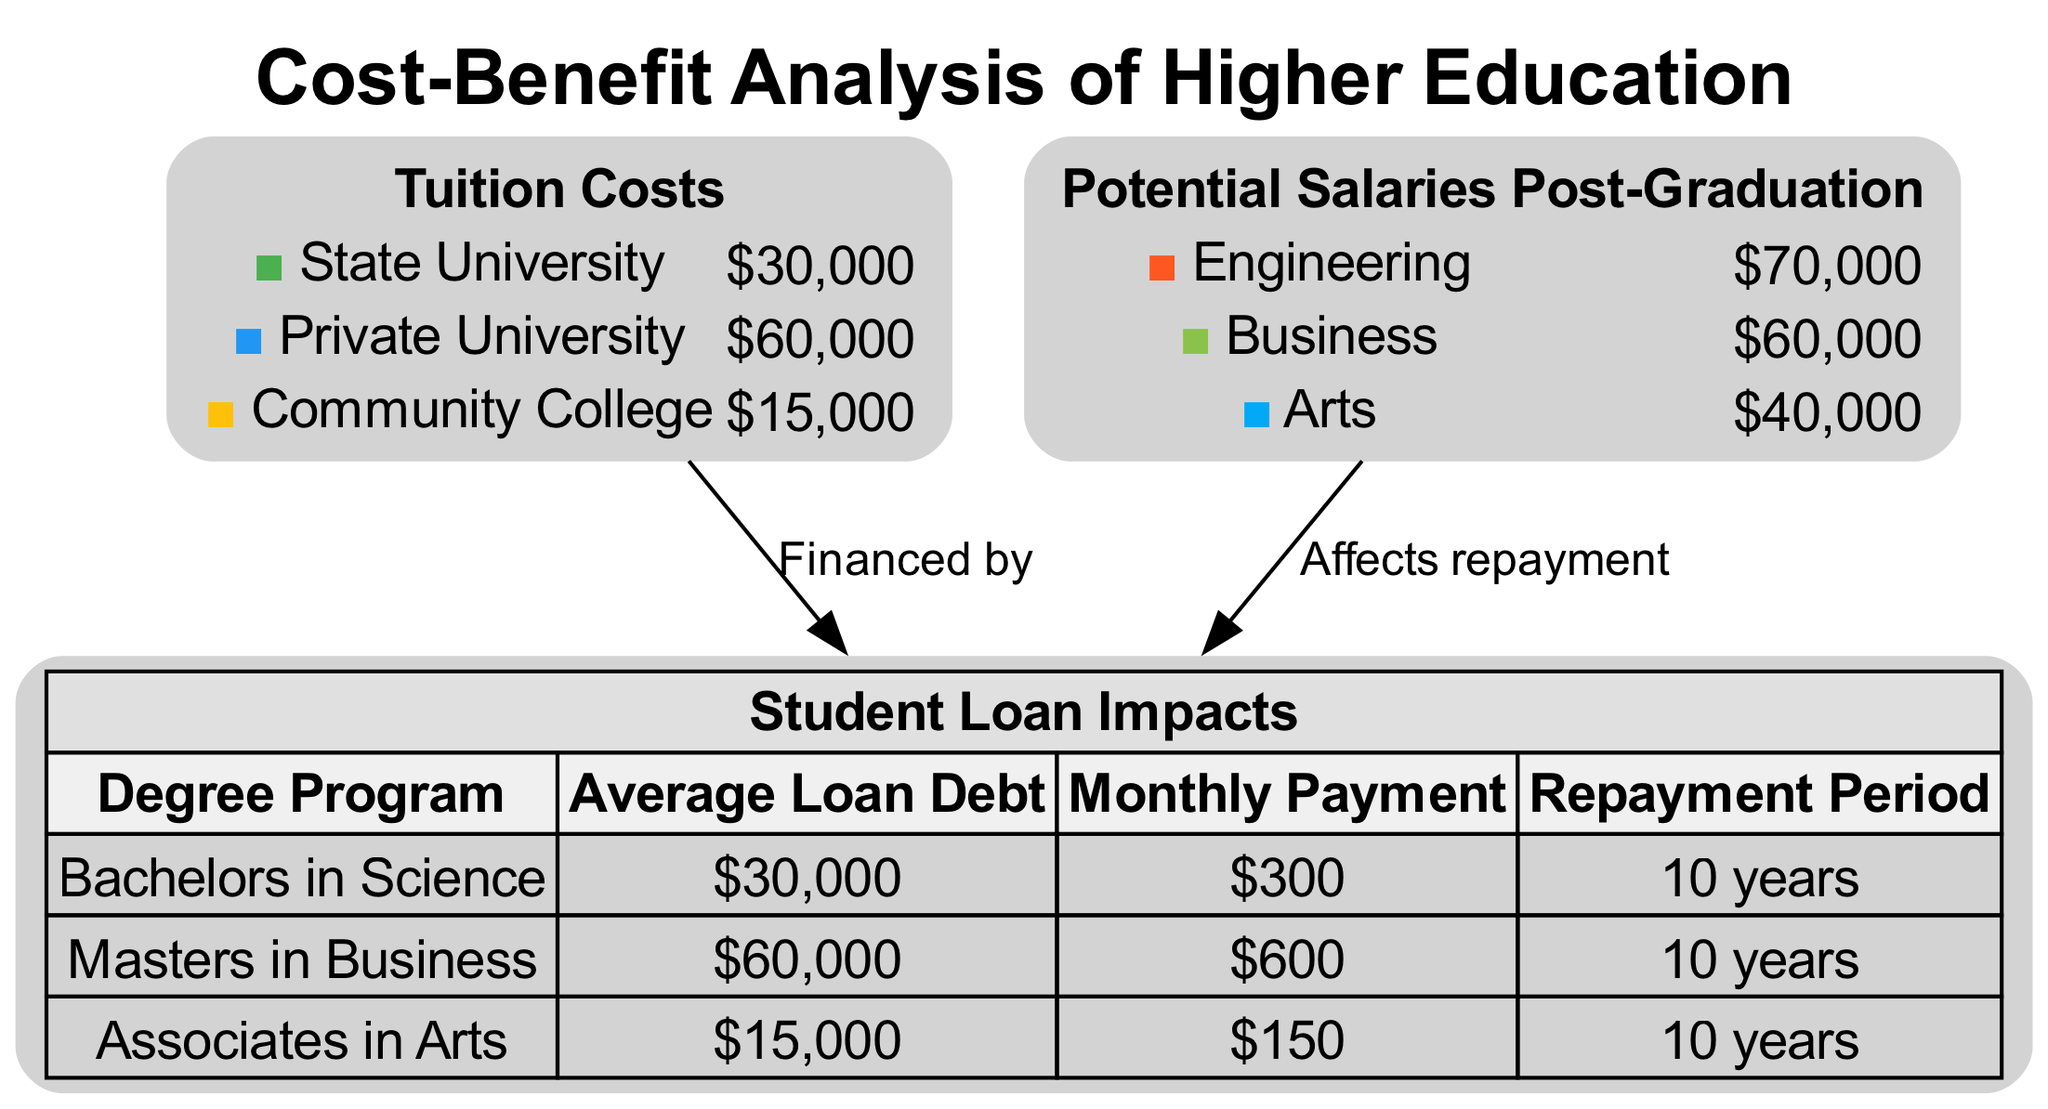What is the tuition cost for a Private University? The diagram shows that the "Private University" segment of the "Tuition Costs" pie chart has a value of $60,000.
Answer: $60,000 What is the monthly payment for a Masters in Business? In the table titled "Student Loan Impacts," the row corresponding to "Masters in Business" indicates an average monthly payment of $600.
Answer: $600 Which degree program has the lowest average loan debt? Referring to the table, the "Associates in Arts" program has the lowest average loan debt listed at $15,000.
Answer: Associates in Arts What is the total number of segments in the Potential Salaries Post-Graduation pie chart? The "Potential Salaries Post-Graduation" pie chart includes three segments: "Engineering," "Business," and "Arts," which gives a total of three segments.
Answer: 3 How much greater is the potential salary for Engineering compared to Arts? The diagram shows that the potential salary for "Engineering" is $70,000 while "Arts" is $40,000. Subtracting these gives a difference of $30,000.
Answer: $30,000 How many edges connect the tuition costs to the student loans? The diagram indicates one edge labeled "Financed by" connecting the "Tuition Costs" pie chart and the "Student Loan Impacts" table.
Answer: 1 Which degree program has the highest repayment impact based on average loan debt? The "Masters in Business" has an average loan debt of $60,000, making it the highest compared to the other programs listed.
Answer: Masters in Business What is the total of tuition costs represented in the pie chart? The tuition costs for State University ($30,000), Private University ($60,000), and Community College ($15,000) total $105,000 when added together.
Answer: $105,000 What color represents the segment for Community College in the Tuition Costs pie chart? The segment for "Community College" in the pie chart is represented by the color yellow, which corresponds to the hex code #FFC107.
Answer: Yellow 